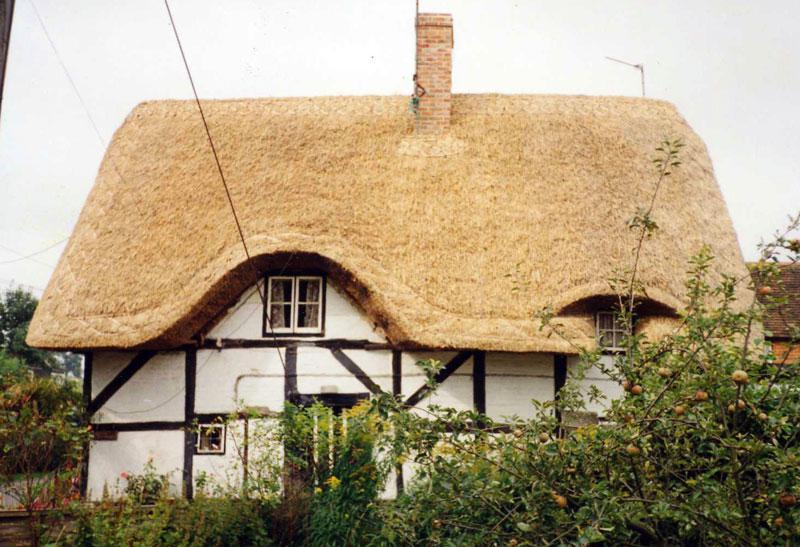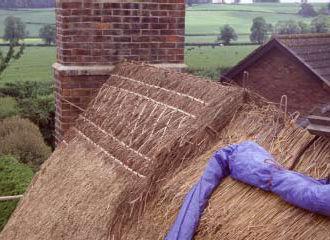The first image is the image on the left, the second image is the image on the right. For the images shown, is this caption "At least one man is standing on a ladder propped against an unfinished thatched roof." true? Answer yes or no. No. The first image is the image on the left, the second image is the image on the right. For the images displayed, is the sentence "Men are repairing a roof." factually correct? Answer yes or no. No. 